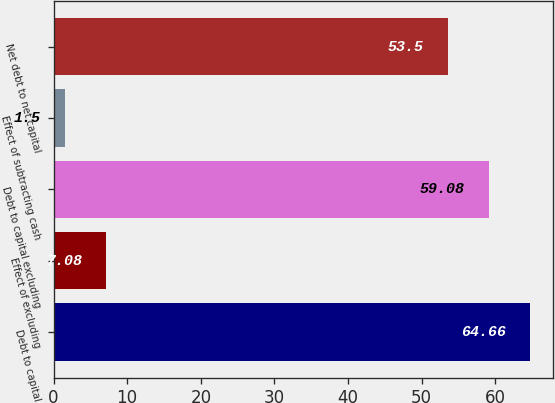Convert chart. <chart><loc_0><loc_0><loc_500><loc_500><bar_chart><fcel>Debt to capital<fcel>Effect of excluding<fcel>Debt to capital excluding<fcel>Effect of subtracting cash<fcel>Net debt to net capital<nl><fcel>64.66<fcel>7.08<fcel>59.08<fcel>1.5<fcel>53.5<nl></chart> 